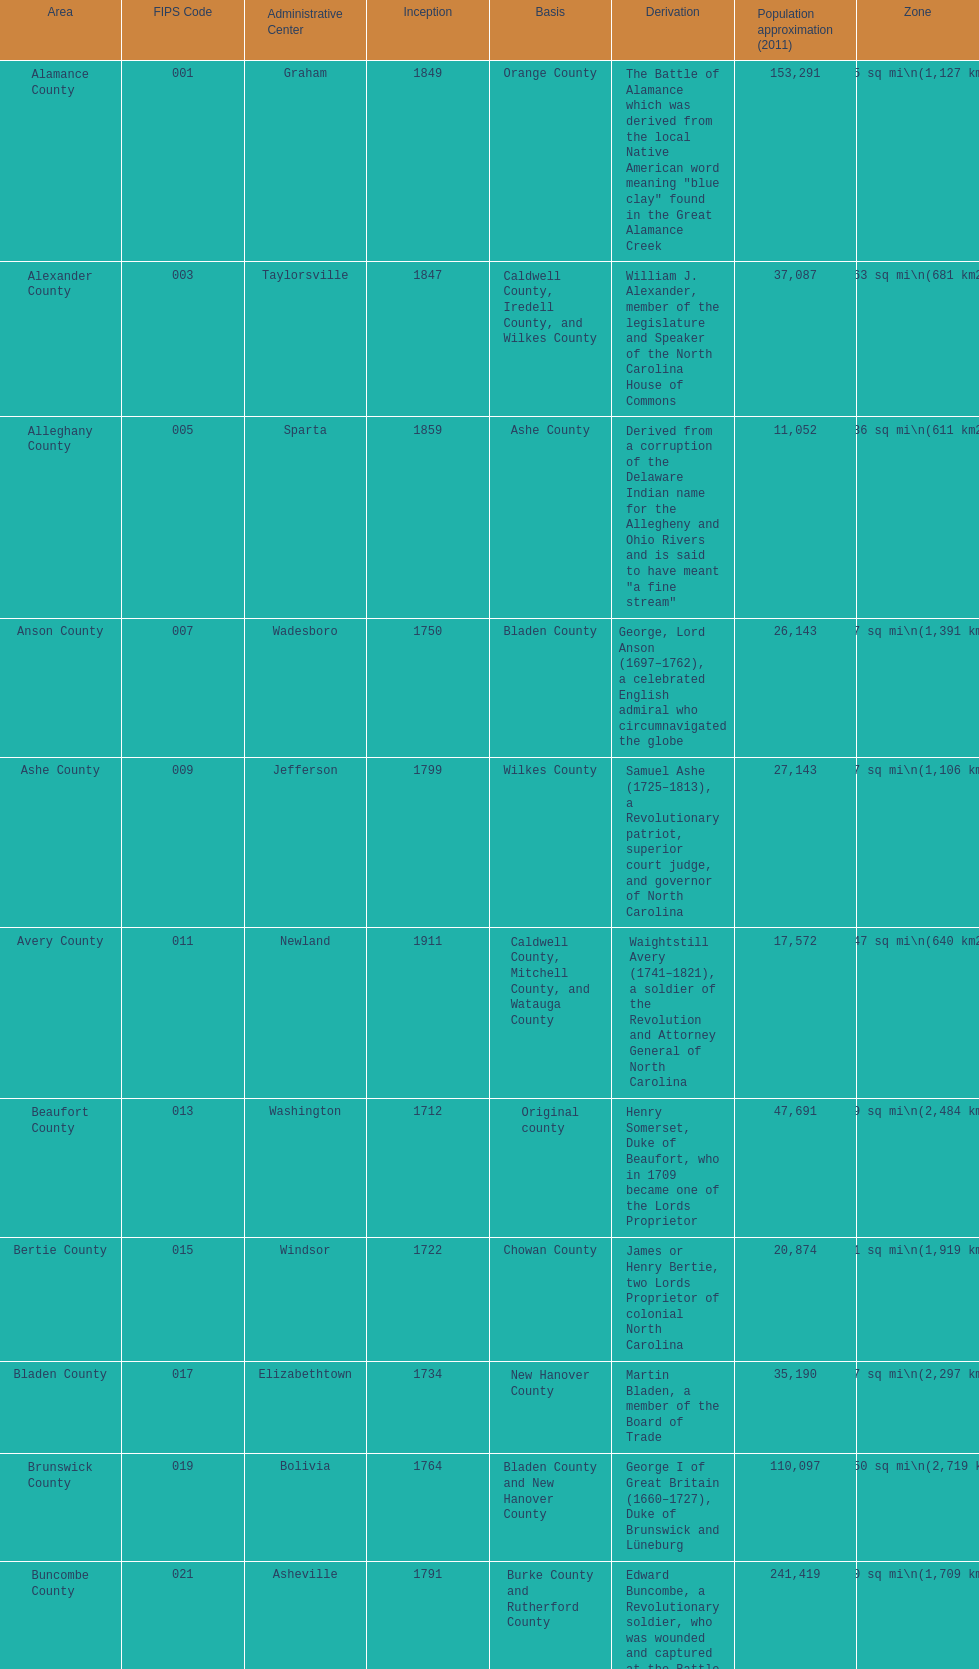What number of counties are named for us presidents? 3. 